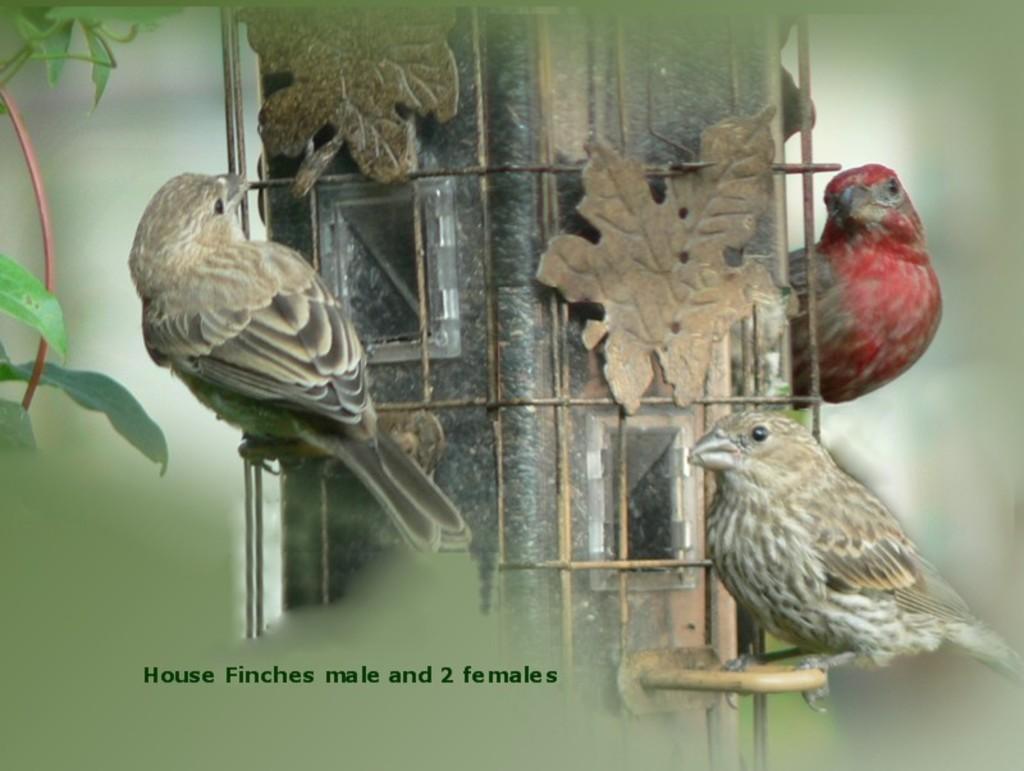In one or two sentences, can you explain what this image depicts? In the center of the image there are birds. To the left side of the image there are leaves. 